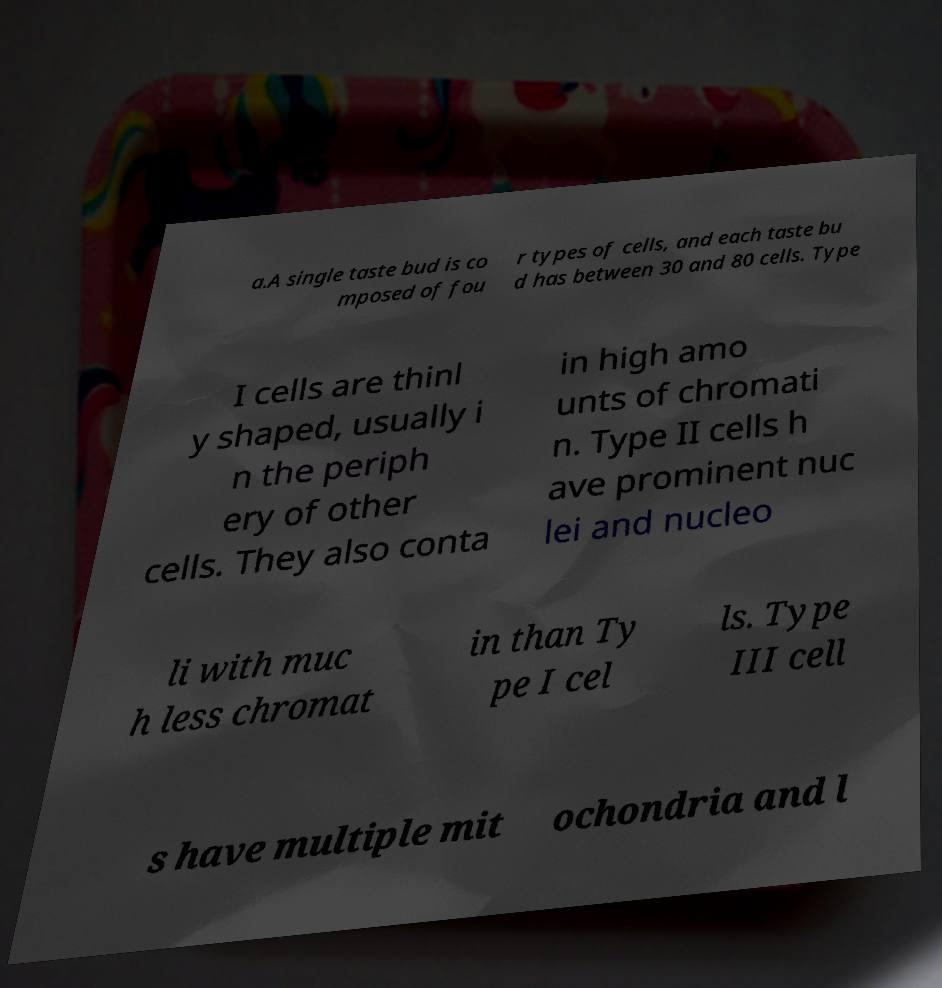For documentation purposes, I need the text within this image transcribed. Could you provide that? a.A single taste bud is co mposed of fou r types of cells, and each taste bu d has between 30 and 80 cells. Type I cells are thinl y shaped, usually i n the periph ery of other cells. They also conta in high amo unts of chromati n. Type II cells h ave prominent nuc lei and nucleo li with muc h less chromat in than Ty pe I cel ls. Type III cell s have multiple mit ochondria and l 